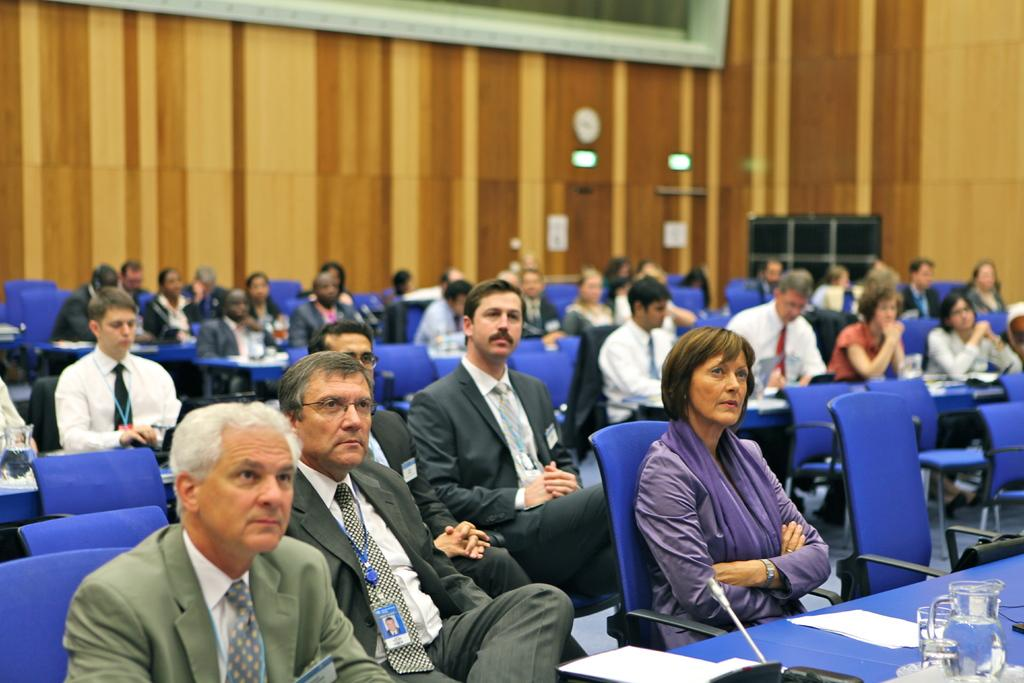What are the people in the image doing? The people in the image are sitting on chairs. What objects can be seen on the bottom right of the image? There is a jar and a glass on the bottom right of the image. What is on the table in the image? There are papers on the table in the image. What can be seen in the background of the image? There is a wall in the background of the image. What type of bear can be seen with fangs in the image? There is no bear or fangs present in the image. What type of oatmeal is being served in the image? There is no oatmeal present in the image. 